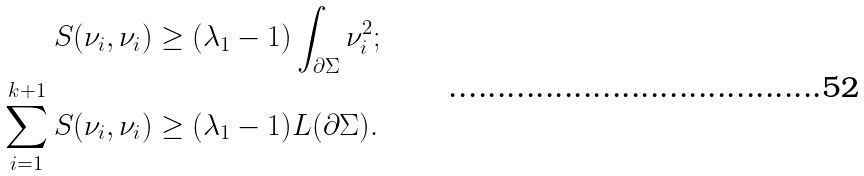Convert formula to latex. <formula><loc_0><loc_0><loc_500><loc_500>S ( \nu _ { i } , \nu _ { i } ) & \geq ( \lambda _ { 1 } - 1 ) \int _ { \partial \Sigma } \nu _ { i } ^ { 2 } ; \\ \sum _ { i = 1 } ^ { k + 1 } S ( \nu _ { i } , \nu _ { i } ) & \geq ( \lambda _ { 1 } - 1 ) L ( \partial \Sigma ) .</formula> 